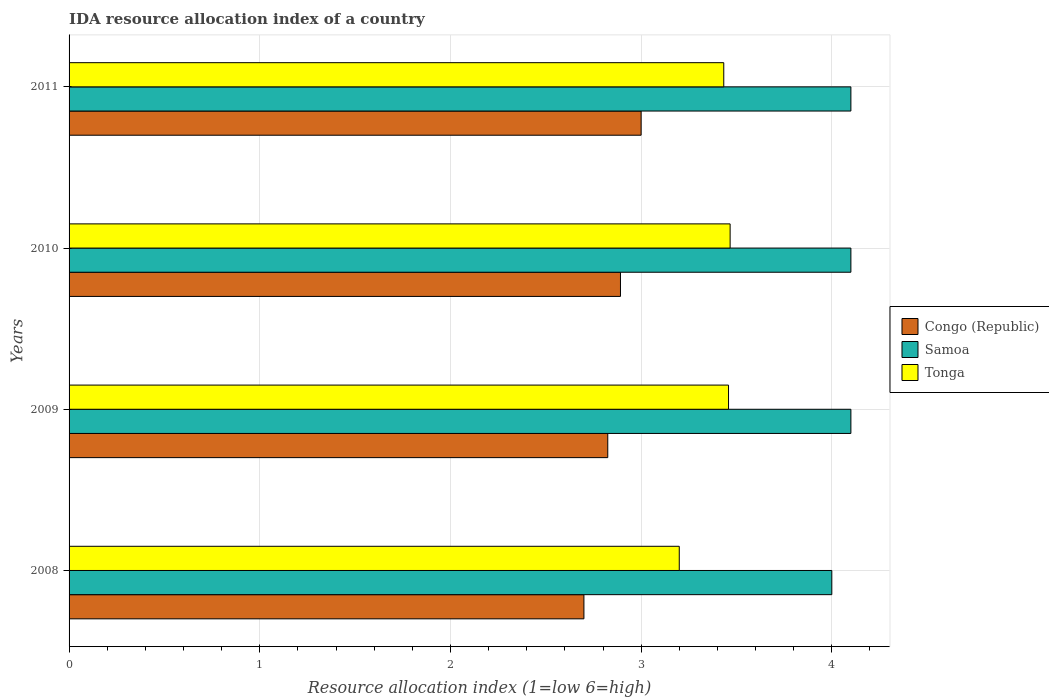How many different coloured bars are there?
Your answer should be very brief. 3. Are the number of bars per tick equal to the number of legend labels?
Offer a very short reply. Yes. How many bars are there on the 3rd tick from the top?
Offer a terse response. 3. How many bars are there on the 3rd tick from the bottom?
Make the answer very short. 3. What is the label of the 2nd group of bars from the top?
Offer a terse response. 2010. Across all years, what is the maximum IDA resource allocation index in Samoa?
Give a very brief answer. 4.1. In which year was the IDA resource allocation index in Samoa maximum?
Keep it short and to the point. 2009. In which year was the IDA resource allocation index in Samoa minimum?
Your response must be concise. 2008. What is the total IDA resource allocation index in Congo (Republic) in the graph?
Your answer should be very brief. 11.42. What is the difference between the IDA resource allocation index in Congo (Republic) in 2008 and that in 2010?
Make the answer very short. -0.19. What is the difference between the IDA resource allocation index in Tonga in 2011 and the IDA resource allocation index in Congo (Republic) in 2008?
Offer a very short reply. 0.73. What is the average IDA resource allocation index in Samoa per year?
Offer a terse response. 4.07. In how many years, is the IDA resource allocation index in Tonga greater than 3.2 ?
Provide a short and direct response. 3. What is the ratio of the IDA resource allocation index in Samoa in 2008 to that in 2011?
Your answer should be compact. 0.98. What is the difference between the highest and the second highest IDA resource allocation index in Congo (Republic)?
Ensure brevity in your answer.  0.11. What is the difference between the highest and the lowest IDA resource allocation index in Tonga?
Make the answer very short. 0.27. What does the 3rd bar from the top in 2011 represents?
Your answer should be very brief. Congo (Republic). What does the 2nd bar from the bottom in 2009 represents?
Your response must be concise. Samoa. Is it the case that in every year, the sum of the IDA resource allocation index in Samoa and IDA resource allocation index in Congo (Republic) is greater than the IDA resource allocation index in Tonga?
Your answer should be compact. Yes. How many bars are there?
Ensure brevity in your answer.  12. Where does the legend appear in the graph?
Offer a terse response. Center right. What is the title of the graph?
Your answer should be very brief. IDA resource allocation index of a country. What is the label or title of the X-axis?
Ensure brevity in your answer.  Resource allocation index (1=low 6=high). What is the label or title of the Y-axis?
Your response must be concise. Years. What is the Resource allocation index (1=low 6=high) in Congo (Republic) in 2008?
Provide a short and direct response. 2.7. What is the Resource allocation index (1=low 6=high) in Samoa in 2008?
Your answer should be compact. 4. What is the Resource allocation index (1=low 6=high) of Tonga in 2008?
Your answer should be compact. 3.2. What is the Resource allocation index (1=low 6=high) of Congo (Republic) in 2009?
Your response must be concise. 2.83. What is the Resource allocation index (1=low 6=high) in Tonga in 2009?
Your answer should be compact. 3.46. What is the Resource allocation index (1=low 6=high) in Congo (Republic) in 2010?
Keep it short and to the point. 2.89. What is the Resource allocation index (1=low 6=high) of Tonga in 2010?
Provide a short and direct response. 3.47. What is the Resource allocation index (1=low 6=high) of Samoa in 2011?
Ensure brevity in your answer.  4.1. What is the Resource allocation index (1=low 6=high) of Tonga in 2011?
Your answer should be very brief. 3.43. Across all years, what is the maximum Resource allocation index (1=low 6=high) of Samoa?
Offer a terse response. 4.1. Across all years, what is the maximum Resource allocation index (1=low 6=high) in Tonga?
Give a very brief answer. 3.47. Across all years, what is the minimum Resource allocation index (1=low 6=high) of Samoa?
Offer a terse response. 4. What is the total Resource allocation index (1=low 6=high) in Congo (Republic) in the graph?
Offer a terse response. 11.42. What is the total Resource allocation index (1=low 6=high) of Tonga in the graph?
Offer a very short reply. 13.56. What is the difference between the Resource allocation index (1=low 6=high) in Congo (Republic) in 2008 and that in 2009?
Provide a succinct answer. -0.12. What is the difference between the Resource allocation index (1=low 6=high) of Samoa in 2008 and that in 2009?
Make the answer very short. -0.1. What is the difference between the Resource allocation index (1=low 6=high) in Tonga in 2008 and that in 2009?
Your answer should be compact. -0.26. What is the difference between the Resource allocation index (1=low 6=high) in Congo (Republic) in 2008 and that in 2010?
Ensure brevity in your answer.  -0.19. What is the difference between the Resource allocation index (1=low 6=high) of Samoa in 2008 and that in 2010?
Provide a short and direct response. -0.1. What is the difference between the Resource allocation index (1=low 6=high) of Tonga in 2008 and that in 2010?
Your answer should be compact. -0.27. What is the difference between the Resource allocation index (1=low 6=high) of Congo (Republic) in 2008 and that in 2011?
Your response must be concise. -0.3. What is the difference between the Resource allocation index (1=low 6=high) in Samoa in 2008 and that in 2011?
Make the answer very short. -0.1. What is the difference between the Resource allocation index (1=low 6=high) in Tonga in 2008 and that in 2011?
Offer a terse response. -0.23. What is the difference between the Resource allocation index (1=low 6=high) of Congo (Republic) in 2009 and that in 2010?
Provide a short and direct response. -0.07. What is the difference between the Resource allocation index (1=low 6=high) in Samoa in 2009 and that in 2010?
Give a very brief answer. 0. What is the difference between the Resource allocation index (1=low 6=high) of Tonga in 2009 and that in 2010?
Offer a terse response. -0.01. What is the difference between the Resource allocation index (1=low 6=high) in Congo (Republic) in 2009 and that in 2011?
Provide a succinct answer. -0.17. What is the difference between the Resource allocation index (1=low 6=high) of Samoa in 2009 and that in 2011?
Make the answer very short. 0. What is the difference between the Resource allocation index (1=low 6=high) in Tonga in 2009 and that in 2011?
Make the answer very short. 0.03. What is the difference between the Resource allocation index (1=low 6=high) in Congo (Republic) in 2010 and that in 2011?
Your response must be concise. -0.11. What is the difference between the Resource allocation index (1=low 6=high) of Samoa in 2010 and that in 2011?
Your answer should be compact. 0. What is the difference between the Resource allocation index (1=low 6=high) in Tonga in 2010 and that in 2011?
Provide a short and direct response. 0.03. What is the difference between the Resource allocation index (1=low 6=high) in Congo (Republic) in 2008 and the Resource allocation index (1=low 6=high) in Samoa in 2009?
Give a very brief answer. -1.4. What is the difference between the Resource allocation index (1=low 6=high) of Congo (Republic) in 2008 and the Resource allocation index (1=low 6=high) of Tonga in 2009?
Your answer should be compact. -0.76. What is the difference between the Resource allocation index (1=low 6=high) in Samoa in 2008 and the Resource allocation index (1=low 6=high) in Tonga in 2009?
Your answer should be very brief. 0.54. What is the difference between the Resource allocation index (1=low 6=high) of Congo (Republic) in 2008 and the Resource allocation index (1=low 6=high) of Tonga in 2010?
Provide a short and direct response. -0.77. What is the difference between the Resource allocation index (1=low 6=high) in Samoa in 2008 and the Resource allocation index (1=low 6=high) in Tonga in 2010?
Your response must be concise. 0.53. What is the difference between the Resource allocation index (1=low 6=high) in Congo (Republic) in 2008 and the Resource allocation index (1=low 6=high) in Tonga in 2011?
Ensure brevity in your answer.  -0.73. What is the difference between the Resource allocation index (1=low 6=high) of Samoa in 2008 and the Resource allocation index (1=low 6=high) of Tonga in 2011?
Your answer should be compact. 0.57. What is the difference between the Resource allocation index (1=low 6=high) in Congo (Republic) in 2009 and the Resource allocation index (1=low 6=high) in Samoa in 2010?
Provide a succinct answer. -1.27. What is the difference between the Resource allocation index (1=low 6=high) of Congo (Republic) in 2009 and the Resource allocation index (1=low 6=high) of Tonga in 2010?
Offer a very short reply. -0.64. What is the difference between the Resource allocation index (1=low 6=high) of Samoa in 2009 and the Resource allocation index (1=low 6=high) of Tonga in 2010?
Provide a succinct answer. 0.63. What is the difference between the Resource allocation index (1=low 6=high) in Congo (Republic) in 2009 and the Resource allocation index (1=low 6=high) in Samoa in 2011?
Offer a terse response. -1.27. What is the difference between the Resource allocation index (1=low 6=high) of Congo (Republic) in 2009 and the Resource allocation index (1=low 6=high) of Tonga in 2011?
Keep it short and to the point. -0.61. What is the difference between the Resource allocation index (1=low 6=high) in Samoa in 2009 and the Resource allocation index (1=low 6=high) in Tonga in 2011?
Make the answer very short. 0.67. What is the difference between the Resource allocation index (1=low 6=high) of Congo (Republic) in 2010 and the Resource allocation index (1=low 6=high) of Samoa in 2011?
Make the answer very short. -1.21. What is the difference between the Resource allocation index (1=low 6=high) of Congo (Republic) in 2010 and the Resource allocation index (1=low 6=high) of Tonga in 2011?
Provide a succinct answer. -0.54. What is the difference between the Resource allocation index (1=low 6=high) in Samoa in 2010 and the Resource allocation index (1=low 6=high) in Tonga in 2011?
Your answer should be very brief. 0.67. What is the average Resource allocation index (1=low 6=high) of Congo (Republic) per year?
Your response must be concise. 2.85. What is the average Resource allocation index (1=low 6=high) of Samoa per year?
Give a very brief answer. 4.08. What is the average Resource allocation index (1=low 6=high) of Tonga per year?
Keep it short and to the point. 3.39. In the year 2008, what is the difference between the Resource allocation index (1=low 6=high) in Congo (Republic) and Resource allocation index (1=low 6=high) in Tonga?
Give a very brief answer. -0.5. In the year 2008, what is the difference between the Resource allocation index (1=low 6=high) of Samoa and Resource allocation index (1=low 6=high) of Tonga?
Offer a terse response. 0.8. In the year 2009, what is the difference between the Resource allocation index (1=low 6=high) in Congo (Republic) and Resource allocation index (1=low 6=high) in Samoa?
Ensure brevity in your answer.  -1.27. In the year 2009, what is the difference between the Resource allocation index (1=low 6=high) in Congo (Republic) and Resource allocation index (1=low 6=high) in Tonga?
Ensure brevity in your answer.  -0.63. In the year 2009, what is the difference between the Resource allocation index (1=low 6=high) in Samoa and Resource allocation index (1=low 6=high) in Tonga?
Ensure brevity in your answer.  0.64. In the year 2010, what is the difference between the Resource allocation index (1=low 6=high) in Congo (Republic) and Resource allocation index (1=low 6=high) in Samoa?
Your answer should be very brief. -1.21. In the year 2010, what is the difference between the Resource allocation index (1=low 6=high) of Congo (Republic) and Resource allocation index (1=low 6=high) of Tonga?
Provide a short and direct response. -0.57. In the year 2010, what is the difference between the Resource allocation index (1=low 6=high) of Samoa and Resource allocation index (1=low 6=high) of Tonga?
Your answer should be very brief. 0.63. In the year 2011, what is the difference between the Resource allocation index (1=low 6=high) in Congo (Republic) and Resource allocation index (1=low 6=high) in Samoa?
Give a very brief answer. -1.1. In the year 2011, what is the difference between the Resource allocation index (1=low 6=high) of Congo (Republic) and Resource allocation index (1=low 6=high) of Tonga?
Make the answer very short. -0.43. What is the ratio of the Resource allocation index (1=low 6=high) of Congo (Republic) in 2008 to that in 2009?
Make the answer very short. 0.96. What is the ratio of the Resource allocation index (1=low 6=high) of Samoa in 2008 to that in 2009?
Your answer should be very brief. 0.98. What is the ratio of the Resource allocation index (1=low 6=high) in Tonga in 2008 to that in 2009?
Your response must be concise. 0.93. What is the ratio of the Resource allocation index (1=low 6=high) in Congo (Republic) in 2008 to that in 2010?
Provide a succinct answer. 0.93. What is the ratio of the Resource allocation index (1=low 6=high) of Samoa in 2008 to that in 2010?
Your answer should be compact. 0.98. What is the ratio of the Resource allocation index (1=low 6=high) of Tonga in 2008 to that in 2010?
Keep it short and to the point. 0.92. What is the ratio of the Resource allocation index (1=low 6=high) of Samoa in 2008 to that in 2011?
Ensure brevity in your answer.  0.98. What is the ratio of the Resource allocation index (1=low 6=high) in Tonga in 2008 to that in 2011?
Your response must be concise. 0.93. What is the ratio of the Resource allocation index (1=low 6=high) in Congo (Republic) in 2009 to that in 2010?
Your answer should be very brief. 0.98. What is the ratio of the Resource allocation index (1=low 6=high) of Congo (Republic) in 2009 to that in 2011?
Provide a succinct answer. 0.94. What is the ratio of the Resource allocation index (1=low 6=high) in Samoa in 2009 to that in 2011?
Provide a short and direct response. 1. What is the ratio of the Resource allocation index (1=low 6=high) of Tonga in 2009 to that in 2011?
Your answer should be very brief. 1.01. What is the ratio of the Resource allocation index (1=low 6=high) in Congo (Republic) in 2010 to that in 2011?
Your response must be concise. 0.96. What is the ratio of the Resource allocation index (1=low 6=high) of Tonga in 2010 to that in 2011?
Offer a very short reply. 1.01. What is the difference between the highest and the second highest Resource allocation index (1=low 6=high) of Congo (Republic)?
Provide a short and direct response. 0.11. What is the difference between the highest and the second highest Resource allocation index (1=low 6=high) in Samoa?
Make the answer very short. 0. What is the difference between the highest and the second highest Resource allocation index (1=low 6=high) in Tonga?
Offer a terse response. 0.01. What is the difference between the highest and the lowest Resource allocation index (1=low 6=high) of Congo (Republic)?
Give a very brief answer. 0.3. What is the difference between the highest and the lowest Resource allocation index (1=low 6=high) in Tonga?
Give a very brief answer. 0.27. 